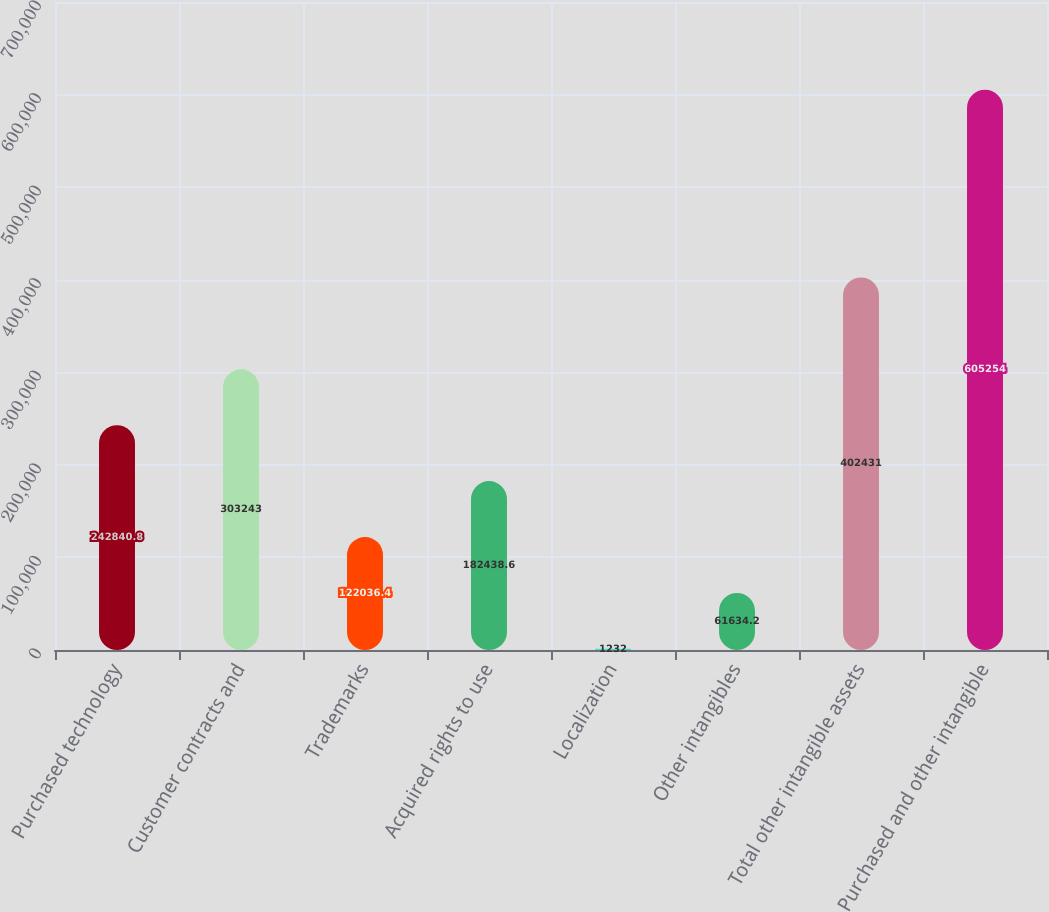Convert chart to OTSL. <chart><loc_0><loc_0><loc_500><loc_500><bar_chart><fcel>Purchased technology<fcel>Customer contracts and<fcel>Trademarks<fcel>Acquired rights to use<fcel>Localization<fcel>Other intangibles<fcel>Total other intangible assets<fcel>Purchased and other intangible<nl><fcel>242841<fcel>303243<fcel>122036<fcel>182439<fcel>1232<fcel>61634.2<fcel>402431<fcel>605254<nl></chart> 